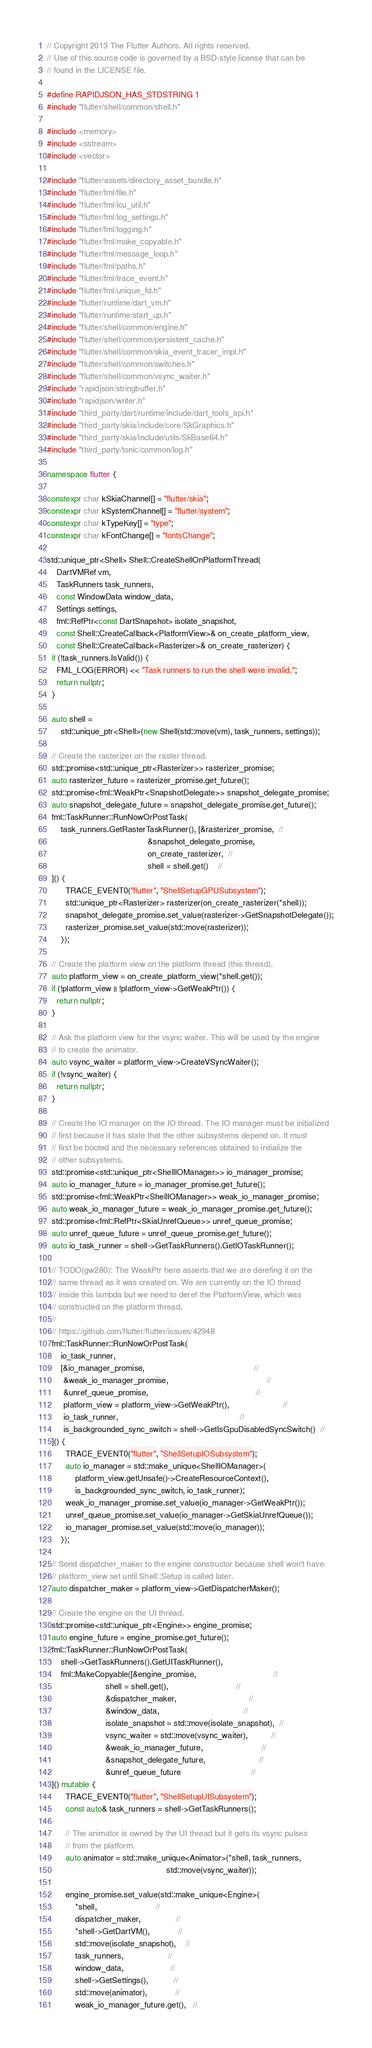<code> <loc_0><loc_0><loc_500><loc_500><_C++_>// Copyright 2013 The Flutter Authors. All rights reserved.
// Use of this source code is governed by a BSD-style license that can be
// found in the LICENSE file.

#define RAPIDJSON_HAS_STDSTRING 1
#include "flutter/shell/common/shell.h"

#include <memory>
#include <sstream>
#include <vector>

#include "flutter/assets/directory_asset_bundle.h"
#include "flutter/fml/file.h"
#include "flutter/fml/icu_util.h"
#include "flutter/fml/log_settings.h"
#include "flutter/fml/logging.h"
#include "flutter/fml/make_copyable.h"
#include "flutter/fml/message_loop.h"
#include "flutter/fml/paths.h"
#include "flutter/fml/trace_event.h"
#include "flutter/fml/unique_fd.h"
#include "flutter/runtime/dart_vm.h"
#include "flutter/runtime/start_up.h"
#include "flutter/shell/common/engine.h"
#include "flutter/shell/common/persistent_cache.h"
#include "flutter/shell/common/skia_event_tracer_impl.h"
#include "flutter/shell/common/switches.h"
#include "flutter/shell/common/vsync_waiter.h"
#include "rapidjson/stringbuffer.h"
#include "rapidjson/writer.h"
#include "third_party/dart/runtime/include/dart_tools_api.h"
#include "third_party/skia/include/core/SkGraphics.h"
#include "third_party/skia/include/utils/SkBase64.h"
#include "third_party/tonic/common/log.h"

namespace flutter {

constexpr char kSkiaChannel[] = "flutter/skia";
constexpr char kSystemChannel[] = "flutter/system";
constexpr char kTypeKey[] = "type";
constexpr char kFontChange[] = "fontsChange";

std::unique_ptr<Shell> Shell::CreateShellOnPlatformThread(
    DartVMRef vm,
    TaskRunners task_runners,
    const WindowData window_data,
    Settings settings,
    fml::RefPtr<const DartSnapshot> isolate_snapshot,
    const Shell::CreateCallback<PlatformView>& on_create_platform_view,
    const Shell::CreateCallback<Rasterizer>& on_create_rasterizer) {
  if (!task_runners.IsValid()) {
    FML_LOG(ERROR) << "Task runners to run the shell were invalid.";
    return nullptr;
  }

  auto shell =
      std::unique_ptr<Shell>(new Shell(std::move(vm), task_runners, settings));

  // Create the rasterizer on the raster thread.
  std::promise<std::unique_ptr<Rasterizer>> rasterizer_promise;
  auto rasterizer_future = rasterizer_promise.get_future();
  std::promise<fml::WeakPtr<SnapshotDelegate>> snapshot_delegate_promise;
  auto snapshot_delegate_future = snapshot_delegate_promise.get_future();
  fml::TaskRunner::RunNowOrPostTask(
      task_runners.GetRasterTaskRunner(), [&rasterizer_promise,  //
                                           &snapshot_delegate_promise,
                                           on_create_rasterizer,  //
                                           shell = shell.get()    //
  ]() {
        TRACE_EVENT0("flutter", "ShellSetupGPUSubsystem");
        std::unique_ptr<Rasterizer> rasterizer(on_create_rasterizer(*shell));
        snapshot_delegate_promise.set_value(rasterizer->GetSnapshotDelegate());
        rasterizer_promise.set_value(std::move(rasterizer));
      });

  // Create the platform view on the platform thread (this thread).
  auto platform_view = on_create_platform_view(*shell.get());
  if (!platform_view || !platform_view->GetWeakPtr()) {
    return nullptr;
  }

  // Ask the platform view for the vsync waiter. This will be used by the engine
  // to create the animator.
  auto vsync_waiter = platform_view->CreateVSyncWaiter();
  if (!vsync_waiter) {
    return nullptr;
  }

  // Create the IO manager on the IO thread. The IO manager must be initialized
  // first because it has state that the other subsystems depend on. It must
  // first be booted and the necessary references obtained to initialize the
  // other subsystems.
  std::promise<std::unique_ptr<ShellIOManager>> io_manager_promise;
  auto io_manager_future = io_manager_promise.get_future();
  std::promise<fml::WeakPtr<ShellIOManager>> weak_io_manager_promise;
  auto weak_io_manager_future = weak_io_manager_promise.get_future();
  std::promise<fml::RefPtr<SkiaUnrefQueue>> unref_queue_promise;
  auto unref_queue_future = unref_queue_promise.get_future();
  auto io_task_runner = shell->GetTaskRunners().GetIOTaskRunner();

  // TODO(gw280): The WeakPtr here asserts that we are derefing it on the
  // same thread as it was created on. We are currently on the IO thread
  // inside this lambda but we need to deref the PlatformView, which was
  // constructed on the platform thread.
  //
  // https://github.com/flutter/flutter/issues/42948
  fml::TaskRunner::RunNowOrPostTask(
      io_task_runner,
      [&io_manager_promise,                                               //
       &weak_io_manager_promise,                                          //
       &unref_queue_promise,                                              //
       platform_view = platform_view->GetWeakPtr(),                       //
       io_task_runner,                                                    //
       is_backgrounded_sync_switch = shell->GetIsGpuDisabledSyncSwitch()  //
  ]() {
        TRACE_EVENT0("flutter", "ShellSetupIOSubsystem");
        auto io_manager = std::make_unique<ShellIOManager>(
            platform_view.getUnsafe()->CreateResourceContext(),
            is_backgrounded_sync_switch, io_task_runner);
        weak_io_manager_promise.set_value(io_manager->GetWeakPtr());
        unref_queue_promise.set_value(io_manager->GetSkiaUnrefQueue());
        io_manager_promise.set_value(std::move(io_manager));
      });

  // Send dispatcher_maker to the engine constructor because shell won't have
  // platform_view set until Shell::Setup is called later.
  auto dispatcher_maker = platform_view->GetDispatcherMaker();

  // Create the engine on the UI thread.
  std::promise<std::unique_ptr<Engine>> engine_promise;
  auto engine_future = engine_promise.get_future();
  fml::TaskRunner::RunNowOrPostTask(
      shell->GetTaskRunners().GetUITaskRunner(),
      fml::MakeCopyable([&engine_promise,                                 //
                         shell = shell.get(),                             //
                         &dispatcher_maker,                               //
                         &window_data,                                    //
                         isolate_snapshot = std::move(isolate_snapshot),  //
                         vsync_waiter = std::move(vsync_waiter),          //
                         &weak_io_manager_future,                         //
                         &snapshot_delegate_future,                       //
                         &unref_queue_future                              //
  ]() mutable {
        TRACE_EVENT0("flutter", "ShellSetupUISubsystem");
        const auto& task_runners = shell->GetTaskRunners();

        // The animator is owned by the UI thread but it gets its vsync pulses
        // from the platform.
        auto animator = std::make_unique<Animator>(*shell, task_runners,
                                                   std::move(vsync_waiter));

        engine_promise.set_value(std::make_unique<Engine>(
            *shell,                         //
            dispatcher_maker,               //
            *shell->GetDartVM(),            //
            std::move(isolate_snapshot),    //
            task_runners,                   //
            window_data,                    //
            shell->GetSettings(),           //
            std::move(animator),            //
            weak_io_manager_future.get(),   //</code> 